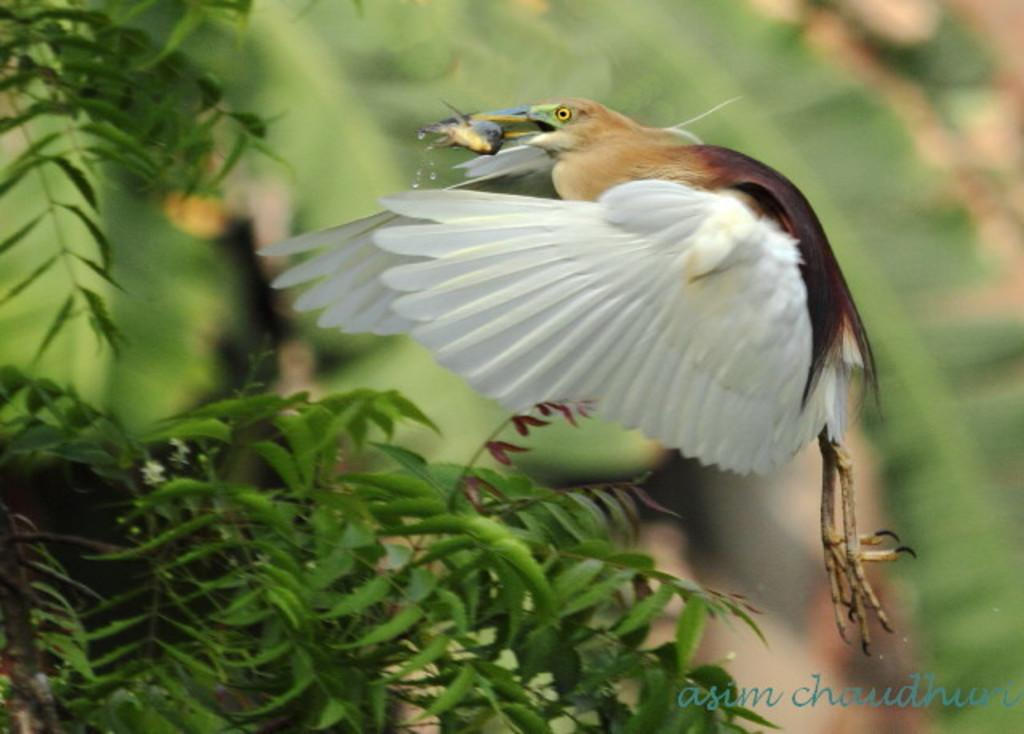What animal can be seen in the image? There is a bird in the image. What is the bird holding in its beak? The bird is holding a fish. Can you describe the coloring of the bird? The bird has brown and white coloring. What type of vegetation is present in the image? There are green plants in the image. How would you describe the background of the image? The background of the image is blurred. How far away is the question mark from the bird in the image? There is no question mark present in the image. Can you describe the coloring of the frog in the image? There is no frog present in the image. 